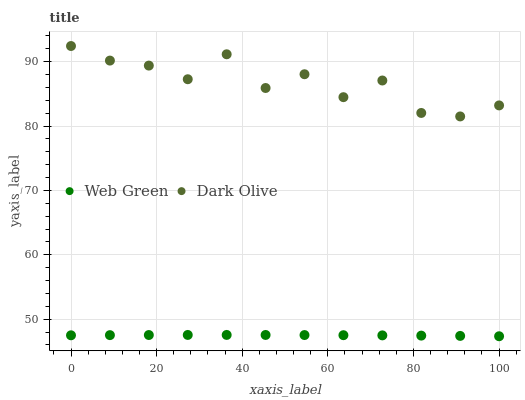Does Web Green have the minimum area under the curve?
Answer yes or no. Yes. Does Dark Olive have the maximum area under the curve?
Answer yes or no. Yes. Does Web Green have the maximum area under the curve?
Answer yes or no. No. Is Web Green the smoothest?
Answer yes or no. Yes. Is Dark Olive the roughest?
Answer yes or no. Yes. Is Web Green the roughest?
Answer yes or no. No. Does Web Green have the lowest value?
Answer yes or no. Yes. Does Dark Olive have the highest value?
Answer yes or no. Yes. Does Web Green have the highest value?
Answer yes or no. No. Is Web Green less than Dark Olive?
Answer yes or no. Yes. Is Dark Olive greater than Web Green?
Answer yes or no. Yes. Does Web Green intersect Dark Olive?
Answer yes or no. No. 